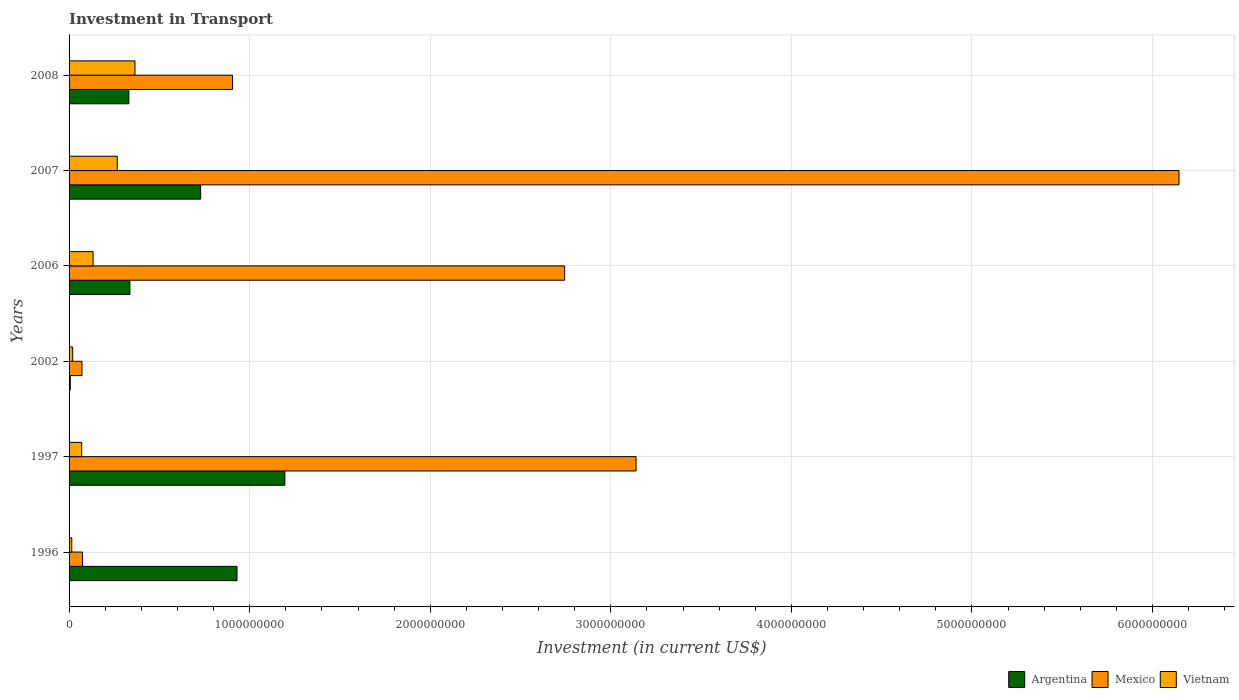How many different coloured bars are there?
Keep it short and to the point. 3. How many groups of bars are there?
Your answer should be very brief. 6. Are the number of bars per tick equal to the number of legend labels?
Ensure brevity in your answer.  Yes. Are the number of bars on each tick of the Y-axis equal?
Offer a terse response. Yes. How many bars are there on the 5th tick from the top?
Your response must be concise. 3. How many bars are there on the 6th tick from the bottom?
Your response must be concise. 3. In how many cases, is the number of bars for a given year not equal to the number of legend labels?
Offer a very short reply. 0. What is the amount invested in transport in Mexico in 1997?
Keep it short and to the point. 3.14e+09. Across all years, what is the maximum amount invested in transport in Mexico?
Offer a very short reply. 6.15e+09. Across all years, what is the minimum amount invested in transport in Argentina?
Offer a very short reply. 6.90e+06. What is the total amount invested in transport in Mexico in the graph?
Your response must be concise. 1.31e+1. What is the difference between the amount invested in transport in Mexico in 2002 and that in 2007?
Your response must be concise. -6.08e+09. What is the difference between the amount invested in transport in Vietnam in 2008 and the amount invested in transport in Argentina in 2002?
Your answer should be very brief. 3.58e+08. What is the average amount invested in transport in Mexico per year?
Your response must be concise. 2.18e+09. In the year 2006, what is the difference between the amount invested in transport in Vietnam and amount invested in transport in Argentina?
Your response must be concise. -2.04e+08. In how many years, is the amount invested in transport in Vietnam greater than 800000000 US$?
Provide a succinct answer. 0. What is the ratio of the amount invested in transport in Vietnam in 1997 to that in 2002?
Your response must be concise. 3.5. What is the difference between the highest and the second highest amount invested in transport in Vietnam?
Your answer should be compact. 9.80e+07. What is the difference between the highest and the lowest amount invested in transport in Argentina?
Make the answer very short. 1.19e+09. Is the sum of the amount invested in transport in Argentina in 1997 and 2008 greater than the maximum amount invested in transport in Mexico across all years?
Your answer should be very brief. No. What does the 3rd bar from the top in 2002 represents?
Your response must be concise. Argentina. What does the 2nd bar from the bottom in 2006 represents?
Ensure brevity in your answer.  Mexico. How many bars are there?
Provide a succinct answer. 18. How many years are there in the graph?
Keep it short and to the point. 6. What is the difference between two consecutive major ticks on the X-axis?
Offer a terse response. 1.00e+09. How many legend labels are there?
Give a very brief answer. 3. How are the legend labels stacked?
Your response must be concise. Horizontal. What is the title of the graph?
Your answer should be compact. Investment in Transport. What is the label or title of the X-axis?
Provide a short and direct response. Investment (in current US$). What is the label or title of the Y-axis?
Your response must be concise. Years. What is the Investment (in current US$) of Argentina in 1996?
Provide a succinct answer. 9.30e+08. What is the Investment (in current US$) in Mexico in 1996?
Make the answer very short. 7.41e+07. What is the Investment (in current US$) in Vietnam in 1996?
Your answer should be very brief. 1.50e+07. What is the Investment (in current US$) in Argentina in 1997?
Your answer should be compact. 1.20e+09. What is the Investment (in current US$) in Mexico in 1997?
Provide a succinct answer. 3.14e+09. What is the Investment (in current US$) of Vietnam in 1997?
Offer a very short reply. 7.00e+07. What is the Investment (in current US$) in Argentina in 2002?
Provide a short and direct response. 6.90e+06. What is the Investment (in current US$) of Mexico in 2002?
Ensure brevity in your answer.  7.14e+07. What is the Investment (in current US$) in Vietnam in 2002?
Keep it short and to the point. 2.00e+07. What is the Investment (in current US$) in Argentina in 2006?
Provide a succinct answer. 3.37e+08. What is the Investment (in current US$) of Mexico in 2006?
Make the answer very short. 2.74e+09. What is the Investment (in current US$) of Vietnam in 2006?
Give a very brief answer. 1.33e+08. What is the Investment (in current US$) of Argentina in 2007?
Offer a very short reply. 7.29e+08. What is the Investment (in current US$) in Mexico in 2007?
Provide a succinct answer. 6.15e+09. What is the Investment (in current US$) of Vietnam in 2007?
Keep it short and to the point. 2.67e+08. What is the Investment (in current US$) of Argentina in 2008?
Provide a succinct answer. 3.31e+08. What is the Investment (in current US$) of Mexico in 2008?
Keep it short and to the point. 9.05e+08. What is the Investment (in current US$) in Vietnam in 2008?
Keep it short and to the point. 3.65e+08. Across all years, what is the maximum Investment (in current US$) in Argentina?
Keep it short and to the point. 1.20e+09. Across all years, what is the maximum Investment (in current US$) in Mexico?
Provide a short and direct response. 6.15e+09. Across all years, what is the maximum Investment (in current US$) of Vietnam?
Your answer should be very brief. 3.65e+08. Across all years, what is the minimum Investment (in current US$) of Argentina?
Make the answer very short. 6.90e+06. Across all years, what is the minimum Investment (in current US$) in Mexico?
Offer a very short reply. 7.14e+07. Across all years, what is the minimum Investment (in current US$) of Vietnam?
Provide a short and direct response. 1.50e+07. What is the total Investment (in current US$) of Argentina in the graph?
Provide a succinct answer. 3.53e+09. What is the total Investment (in current US$) of Mexico in the graph?
Offer a very short reply. 1.31e+1. What is the total Investment (in current US$) in Vietnam in the graph?
Ensure brevity in your answer.  8.70e+08. What is the difference between the Investment (in current US$) in Argentina in 1996 and that in 1997?
Make the answer very short. -2.65e+08. What is the difference between the Investment (in current US$) of Mexico in 1996 and that in 1997?
Keep it short and to the point. -3.07e+09. What is the difference between the Investment (in current US$) of Vietnam in 1996 and that in 1997?
Provide a short and direct response. -5.50e+07. What is the difference between the Investment (in current US$) of Argentina in 1996 and that in 2002?
Offer a very short reply. 9.23e+08. What is the difference between the Investment (in current US$) of Mexico in 1996 and that in 2002?
Offer a very short reply. 2.70e+06. What is the difference between the Investment (in current US$) of Vietnam in 1996 and that in 2002?
Provide a succinct answer. -5.00e+06. What is the difference between the Investment (in current US$) in Argentina in 1996 and that in 2006?
Your answer should be compact. 5.93e+08. What is the difference between the Investment (in current US$) of Mexico in 1996 and that in 2006?
Offer a terse response. -2.67e+09. What is the difference between the Investment (in current US$) in Vietnam in 1996 and that in 2006?
Your answer should be compact. -1.18e+08. What is the difference between the Investment (in current US$) of Argentina in 1996 and that in 2007?
Offer a terse response. 2.01e+08. What is the difference between the Investment (in current US$) in Mexico in 1996 and that in 2007?
Ensure brevity in your answer.  -6.07e+09. What is the difference between the Investment (in current US$) in Vietnam in 1996 and that in 2007?
Your response must be concise. -2.52e+08. What is the difference between the Investment (in current US$) of Argentina in 1996 and that in 2008?
Your response must be concise. 5.99e+08. What is the difference between the Investment (in current US$) of Mexico in 1996 and that in 2008?
Provide a succinct answer. -8.31e+08. What is the difference between the Investment (in current US$) in Vietnam in 1996 and that in 2008?
Offer a very short reply. -3.50e+08. What is the difference between the Investment (in current US$) in Argentina in 1997 and that in 2002?
Your response must be concise. 1.19e+09. What is the difference between the Investment (in current US$) in Mexico in 1997 and that in 2002?
Ensure brevity in your answer.  3.07e+09. What is the difference between the Investment (in current US$) of Argentina in 1997 and that in 2006?
Give a very brief answer. 8.58e+08. What is the difference between the Investment (in current US$) in Mexico in 1997 and that in 2006?
Offer a very short reply. 3.95e+08. What is the difference between the Investment (in current US$) in Vietnam in 1997 and that in 2006?
Offer a very short reply. -6.30e+07. What is the difference between the Investment (in current US$) of Argentina in 1997 and that in 2007?
Offer a terse response. 4.66e+08. What is the difference between the Investment (in current US$) of Mexico in 1997 and that in 2007?
Offer a terse response. -3.01e+09. What is the difference between the Investment (in current US$) in Vietnam in 1997 and that in 2007?
Provide a short and direct response. -1.97e+08. What is the difference between the Investment (in current US$) in Argentina in 1997 and that in 2008?
Ensure brevity in your answer.  8.64e+08. What is the difference between the Investment (in current US$) in Mexico in 1997 and that in 2008?
Ensure brevity in your answer.  2.23e+09. What is the difference between the Investment (in current US$) of Vietnam in 1997 and that in 2008?
Your answer should be very brief. -2.95e+08. What is the difference between the Investment (in current US$) of Argentina in 2002 and that in 2006?
Your answer should be compact. -3.30e+08. What is the difference between the Investment (in current US$) in Mexico in 2002 and that in 2006?
Your response must be concise. -2.67e+09. What is the difference between the Investment (in current US$) in Vietnam in 2002 and that in 2006?
Your answer should be very brief. -1.13e+08. What is the difference between the Investment (in current US$) of Argentina in 2002 and that in 2007?
Keep it short and to the point. -7.22e+08. What is the difference between the Investment (in current US$) in Mexico in 2002 and that in 2007?
Give a very brief answer. -6.08e+09. What is the difference between the Investment (in current US$) of Vietnam in 2002 and that in 2007?
Keep it short and to the point. -2.47e+08. What is the difference between the Investment (in current US$) of Argentina in 2002 and that in 2008?
Your answer should be compact. -3.24e+08. What is the difference between the Investment (in current US$) of Mexico in 2002 and that in 2008?
Offer a terse response. -8.34e+08. What is the difference between the Investment (in current US$) of Vietnam in 2002 and that in 2008?
Provide a succinct answer. -3.45e+08. What is the difference between the Investment (in current US$) of Argentina in 2006 and that in 2007?
Your answer should be very brief. -3.92e+08. What is the difference between the Investment (in current US$) in Mexico in 2006 and that in 2007?
Give a very brief answer. -3.40e+09. What is the difference between the Investment (in current US$) in Vietnam in 2006 and that in 2007?
Offer a very short reply. -1.34e+08. What is the difference between the Investment (in current US$) of Argentina in 2006 and that in 2008?
Keep it short and to the point. 6.00e+06. What is the difference between the Investment (in current US$) in Mexico in 2006 and that in 2008?
Ensure brevity in your answer.  1.84e+09. What is the difference between the Investment (in current US$) in Vietnam in 2006 and that in 2008?
Keep it short and to the point. -2.32e+08. What is the difference between the Investment (in current US$) in Argentina in 2007 and that in 2008?
Give a very brief answer. 3.98e+08. What is the difference between the Investment (in current US$) in Mexico in 2007 and that in 2008?
Ensure brevity in your answer.  5.24e+09. What is the difference between the Investment (in current US$) of Vietnam in 2007 and that in 2008?
Ensure brevity in your answer.  -9.80e+07. What is the difference between the Investment (in current US$) in Argentina in 1996 and the Investment (in current US$) in Mexico in 1997?
Your answer should be very brief. -2.21e+09. What is the difference between the Investment (in current US$) in Argentina in 1996 and the Investment (in current US$) in Vietnam in 1997?
Your response must be concise. 8.60e+08. What is the difference between the Investment (in current US$) in Mexico in 1996 and the Investment (in current US$) in Vietnam in 1997?
Provide a short and direct response. 4.10e+06. What is the difference between the Investment (in current US$) in Argentina in 1996 and the Investment (in current US$) in Mexico in 2002?
Give a very brief answer. 8.59e+08. What is the difference between the Investment (in current US$) in Argentina in 1996 and the Investment (in current US$) in Vietnam in 2002?
Ensure brevity in your answer.  9.10e+08. What is the difference between the Investment (in current US$) of Mexico in 1996 and the Investment (in current US$) of Vietnam in 2002?
Keep it short and to the point. 5.41e+07. What is the difference between the Investment (in current US$) in Argentina in 1996 and the Investment (in current US$) in Mexico in 2006?
Your answer should be compact. -1.81e+09. What is the difference between the Investment (in current US$) of Argentina in 1996 and the Investment (in current US$) of Vietnam in 2006?
Keep it short and to the point. 7.97e+08. What is the difference between the Investment (in current US$) of Mexico in 1996 and the Investment (in current US$) of Vietnam in 2006?
Keep it short and to the point. -5.89e+07. What is the difference between the Investment (in current US$) in Argentina in 1996 and the Investment (in current US$) in Mexico in 2007?
Provide a succinct answer. -5.22e+09. What is the difference between the Investment (in current US$) in Argentina in 1996 and the Investment (in current US$) in Vietnam in 2007?
Your answer should be very brief. 6.63e+08. What is the difference between the Investment (in current US$) of Mexico in 1996 and the Investment (in current US$) of Vietnam in 2007?
Ensure brevity in your answer.  -1.93e+08. What is the difference between the Investment (in current US$) of Argentina in 1996 and the Investment (in current US$) of Mexico in 2008?
Ensure brevity in your answer.  2.49e+07. What is the difference between the Investment (in current US$) of Argentina in 1996 and the Investment (in current US$) of Vietnam in 2008?
Your answer should be compact. 5.65e+08. What is the difference between the Investment (in current US$) in Mexico in 1996 and the Investment (in current US$) in Vietnam in 2008?
Keep it short and to the point. -2.91e+08. What is the difference between the Investment (in current US$) of Argentina in 1997 and the Investment (in current US$) of Mexico in 2002?
Offer a terse response. 1.12e+09. What is the difference between the Investment (in current US$) of Argentina in 1997 and the Investment (in current US$) of Vietnam in 2002?
Make the answer very short. 1.18e+09. What is the difference between the Investment (in current US$) in Mexico in 1997 and the Investment (in current US$) in Vietnam in 2002?
Give a very brief answer. 3.12e+09. What is the difference between the Investment (in current US$) of Argentina in 1997 and the Investment (in current US$) of Mexico in 2006?
Give a very brief answer. -1.55e+09. What is the difference between the Investment (in current US$) in Argentina in 1997 and the Investment (in current US$) in Vietnam in 2006?
Offer a terse response. 1.06e+09. What is the difference between the Investment (in current US$) in Mexico in 1997 and the Investment (in current US$) in Vietnam in 2006?
Provide a short and direct response. 3.01e+09. What is the difference between the Investment (in current US$) of Argentina in 1997 and the Investment (in current US$) of Mexico in 2007?
Provide a short and direct response. -4.95e+09. What is the difference between the Investment (in current US$) in Argentina in 1997 and the Investment (in current US$) in Vietnam in 2007?
Provide a succinct answer. 9.28e+08. What is the difference between the Investment (in current US$) of Mexico in 1997 and the Investment (in current US$) of Vietnam in 2007?
Your response must be concise. 2.87e+09. What is the difference between the Investment (in current US$) in Argentina in 1997 and the Investment (in current US$) in Mexico in 2008?
Your answer should be compact. 2.90e+08. What is the difference between the Investment (in current US$) in Argentina in 1997 and the Investment (in current US$) in Vietnam in 2008?
Keep it short and to the point. 8.30e+08. What is the difference between the Investment (in current US$) in Mexico in 1997 and the Investment (in current US$) in Vietnam in 2008?
Offer a terse response. 2.77e+09. What is the difference between the Investment (in current US$) in Argentina in 2002 and the Investment (in current US$) in Mexico in 2006?
Your answer should be very brief. -2.74e+09. What is the difference between the Investment (in current US$) in Argentina in 2002 and the Investment (in current US$) in Vietnam in 2006?
Offer a terse response. -1.26e+08. What is the difference between the Investment (in current US$) in Mexico in 2002 and the Investment (in current US$) in Vietnam in 2006?
Ensure brevity in your answer.  -6.16e+07. What is the difference between the Investment (in current US$) in Argentina in 2002 and the Investment (in current US$) in Mexico in 2007?
Make the answer very short. -6.14e+09. What is the difference between the Investment (in current US$) in Argentina in 2002 and the Investment (in current US$) in Vietnam in 2007?
Provide a succinct answer. -2.60e+08. What is the difference between the Investment (in current US$) in Mexico in 2002 and the Investment (in current US$) in Vietnam in 2007?
Provide a succinct answer. -1.96e+08. What is the difference between the Investment (in current US$) in Argentina in 2002 and the Investment (in current US$) in Mexico in 2008?
Give a very brief answer. -8.98e+08. What is the difference between the Investment (in current US$) in Argentina in 2002 and the Investment (in current US$) in Vietnam in 2008?
Make the answer very short. -3.58e+08. What is the difference between the Investment (in current US$) in Mexico in 2002 and the Investment (in current US$) in Vietnam in 2008?
Ensure brevity in your answer.  -2.94e+08. What is the difference between the Investment (in current US$) of Argentina in 2006 and the Investment (in current US$) of Mexico in 2007?
Keep it short and to the point. -5.81e+09. What is the difference between the Investment (in current US$) of Argentina in 2006 and the Investment (in current US$) of Vietnam in 2007?
Your response must be concise. 7.00e+07. What is the difference between the Investment (in current US$) in Mexico in 2006 and the Investment (in current US$) in Vietnam in 2007?
Keep it short and to the point. 2.48e+09. What is the difference between the Investment (in current US$) in Argentina in 2006 and the Investment (in current US$) in Mexico in 2008?
Make the answer very short. -5.68e+08. What is the difference between the Investment (in current US$) in Argentina in 2006 and the Investment (in current US$) in Vietnam in 2008?
Give a very brief answer. -2.80e+07. What is the difference between the Investment (in current US$) of Mexico in 2006 and the Investment (in current US$) of Vietnam in 2008?
Offer a terse response. 2.38e+09. What is the difference between the Investment (in current US$) of Argentina in 2007 and the Investment (in current US$) of Mexico in 2008?
Offer a very short reply. -1.76e+08. What is the difference between the Investment (in current US$) in Argentina in 2007 and the Investment (in current US$) in Vietnam in 2008?
Offer a very short reply. 3.64e+08. What is the difference between the Investment (in current US$) of Mexico in 2007 and the Investment (in current US$) of Vietnam in 2008?
Keep it short and to the point. 5.78e+09. What is the average Investment (in current US$) in Argentina per year?
Make the answer very short. 5.88e+08. What is the average Investment (in current US$) of Mexico per year?
Keep it short and to the point. 2.18e+09. What is the average Investment (in current US$) of Vietnam per year?
Your response must be concise. 1.45e+08. In the year 1996, what is the difference between the Investment (in current US$) of Argentina and Investment (in current US$) of Mexico?
Make the answer very short. 8.56e+08. In the year 1996, what is the difference between the Investment (in current US$) in Argentina and Investment (in current US$) in Vietnam?
Make the answer very short. 9.15e+08. In the year 1996, what is the difference between the Investment (in current US$) of Mexico and Investment (in current US$) of Vietnam?
Your answer should be compact. 5.91e+07. In the year 1997, what is the difference between the Investment (in current US$) in Argentina and Investment (in current US$) in Mexico?
Ensure brevity in your answer.  -1.94e+09. In the year 1997, what is the difference between the Investment (in current US$) in Argentina and Investment (in current US$) in Vietnam?
Your answer should be very brief. 1.12e+09. In the year 1997, what is the difference between the Investment (in current US$) in Mexico and Investment (in current US$) in Vietnam?
Ensure brevity in your answer.  3.07e+09. In the year 2002, what is the difference between the Investment (in current US$) of Argentina and Investment (in current US$) of Mexico?
Provide a short and direct response. -6.45e+07. In the year 2002, what is the difference between the Investment (in current US$) of Argentina and Investment (in current US$) of Vietnam?
Your answer should be compact. -1.31e+07. In the year 2002, what is the difference between the Investment (in current US$) in Mexico and Investment (in current US$) in Vietnam?
Your response must be concise. 5.14e+07. In the year 2006, what is the difference between the Investment (in current US$) of Argentina and Investment (in current US$) of Mexico?
Give a very brief answer. -2.41e+09. In the year 2006, what is the difference between the Investment (in current US$) in Argentina and Investment (in current US$) in Vietnam?
Provide a succinct answer. 2.04e+08. In the year 2006, what is the difference between the Investment (in current US$) in Mexico and Investment (in current US$) in Vietnam?
Provide a short and direct response. 2.61e+09. In the year 2007, what is the difference between the Investment (in current US$) of Argentina and Investment (in current US$) of Mexico?
Ensure brevity in your answer.  -5.42e+09. In the year 2007, what is the difference between the Investment (in current US$) in Argentina and Investment (in current US$) in Vietnam?
Provide a short and direct response. 4.62e+08. In the year 2007, what is the difference between the Investment (in current US$) in Mexico and Investment (in current US$) in Vietnam?
Provide a succinct answer. 5.88e+09. In the year 2008, what is the difference between the Investment (in current US$) of Argentina and Investment (in current US$) of Mexico?
Your response must be concise. -5.74e+08. In the year 2008, what is the difference between the Investment (in current US$) of Argentina and Investment (in current US$) of Vietnam?
Keep it short and to the point. -3.40e+07. In the year 2008, what is the difference between the Investment (in current US$) of Mexico and Investment (in current US$) of Vietnam?
Your answer should be very brief. 5.40e+08. What is the ratio of the Investment (in current US$) of Argentina in 1996 to that in 1997?
Your response must be concise. 0.78. What is the ratio of the Investment (in current US$) of Mexico in 1996 to that in 1997?
Ensure brevity in your answer.  0.02. What is the ratio of the Investment (in current US$) in Vietnam in 1996 to that in 1997?
Your response must be concise. 0.21. What is the ratio of the Investment (in current US$) of Argentina in 1996 to that in 2002?
Your answer should be compact. 134.78. What is the ratio of the Investment (in current US$) in Mexico in 1996 to that in 2002?
Make the answer very short. 1.04. What is the ratio of the Investment (in current US$) of Argentina in 1996 to that in 2006?
Make the answer very short. 2.76. What is the ratio of the Investment (in current US$) of Mexico in 1996 to that in 2006?
Your answer should be very brief. 0.03. What is the ratio of the Investment (in current US$) of Vietnam in 1996 to that in 2006?
Provide a succinct answer. 0.11. What is the ratio of the Investment (in current US$) in Argentina in 1996 to that in 2007?
Provide a succinct answer. 1.28. What is the ratio of the Investment (in current US$) in Mexico in 1996 to that in 2007?
Provide a succinct answer. 0.01. What is the ratio of the Investment (in current US$) of Vietnam in 1996 to that in 2007?
Offer a terse response. 0.06. What is the ratio of the Investment (in current US$) in Argentina in 1996 to that in 2008?
Offer a terse response. 2.81. What is the ratio of the Investment (in current US$) of Mexico in 1996 to that in 2008?
Keep it short and to the point. 0.08. What is the ratio of the Investment (in current US$) in Vietnam in 1996 to that in 2008?
Ensure brevity in your answer.  0.04. What is the ratio of the Investment (in current US$) in Argentina in 1997 to that in 2002?
Provide a succinct answer. 173.19. What is the ratio of the Investment (in current US$) of Mexico in 1997 to that in 2002?
Keep it short and to the point. 43.97. What is the ratio of the Investment (in current US$) in Vietnam in 1997 to that in 2002?
Ensure brevity in your answer.  3.5. What is the ratio of the Investment (in current US$) in Argentina in 1997 to that in 2006?
Your answer should be very brief. 3.55. What is the ratio of the Investment (in current US$) in Mexico in 1997 to that in 2006?
Keep it short and to the point. 1.14. What is the ratio of the Investment (in current US$) in Vietnam in 1997 to that in 2006?
Provide a succinct answer. 0.53. What is the ratio of the Investment (in current US$) of Argentina in 1997 to that in 2007?
Offer a very short reply. 1.64. What is the ratio of the Investment (in current US$) in Mexico in 1997 to that in 2007?
Offer a terse response. 0.51. What is the ratio of the Investment (in current US$) in Vietnam in 1997 to that in 2007?
Your answer should be compact. 0.26. What is the ratio of the Investment (in current US$) of Argentina in 1997 to that in 2008?
Keep it short and to the point. 3.61. What is the ratio of the Investment (in current US$) in Mexico in 1997 to that in 2008?
Offer a terse response. 3.47. What is the ratio of the Investment (in current US$) of Vietnam in 1997 to that in 2008?
Offer a very short reply. 0.19. What is the ratio of the Investment (in current US$) in Argentina in 2002 to that in 2006?
Give a very brief answer. 0.02. What is the ratio of the Investment (in current US$) of Mexico in 2002 to that in 2006?
Keep it short and to the point. 0.03. What is the ratio of the Investment (in current US$) of Vietnam in 2002 to that in 2006?
Your answer should be very brief. 0.15. What is the ratio of the Investment (in current US$) of Argentina in 2002 to that in 2007?
Offer a terse response. 0.01. What is the ratio of the Investment (in current US$) of Mexico in 2002 to that in 2007?
Ensure brevity in your answer.  0.01. What is the ratio of the Investment (in current US$) in Vietnam in 2002 to that in 2007?
Give a very brief answer. 0.07. What is the ratio of the Investment (in current US$) in Argentina in 2002 to that in 2008?
Keep it short and to the point. 0.02. What is the ratio of the Investment (in current US$) of Mexico in 2002 to that in 2008?
Keep it short and to the point. 0.08. What is the ratio of the Investment (in current US$) in Vietnam in 2002 to that in 2008?
Make the answer very short. 0.05. What is the ratio of the Investment (in current US$) in Argentina in 2006 to that in 2007?
Offer a very short reply. 0.46. What is the ratio of the Investment (in current US$) of Mexico in 2006 to that in 2007?
Give a very brief answer. 0.45. What is the ratio of the Investment (in current US$) in Vietnam in 2006 to that in 2007?
Give a very brief answer. 0.5. What is the ratio of the Investment (in current US$) of Argentina in 2006 to that in 2008?
Provide a short and direct response. 1.02. What is the ratio of the Investment (in current US$) of Mexico in 2006 to that in 2008?
Ensure brevity in your answer.  3.03. What is the ratio of the Investment (in current US$) of Vietnam in 2006 to that in 2008?
Give a very brief answer. 0.36. What is the ratio of the Investment (in current US$) of Argentina in 2007 to that in 2008?
Give a very brief answer. 2.2. What is the ratio of the Investment (in current US$) in Mexico in 2007 to that in 2008?
Your response must be concise. 6.79. What is the ratio of the Investment (in current US$) in Vietnam in 2007 to that in 2008?
Your answer should be very brief. 0.73. What is the difference between the highest and the second highest Investment (in current US$) of Argentina?
Provide a short and direct response. 2.65e+08. What is the difference between the highest and the second highest Investment (in current US$) of Mexico?
Your response must be concise. 3.01e+09. What is the difference between the highest and the second highest Investment (in current US$) of Vietnam?
Ensure brevity in your answer.  9.80e+07. What is the difference between the highest and the lowest Investment (in current US$) of Argentina?
Offer a very short reply. 1.19e+09. What is the difference between the highest and the lowest Investment (in current US$) in Mexico?
Provide a short and direct response. 6.08e+09. What is the difference between the highest and the lowest Investment (in current US$) in Vietnam?
Keep it short and to the point. 3.50e+08. 